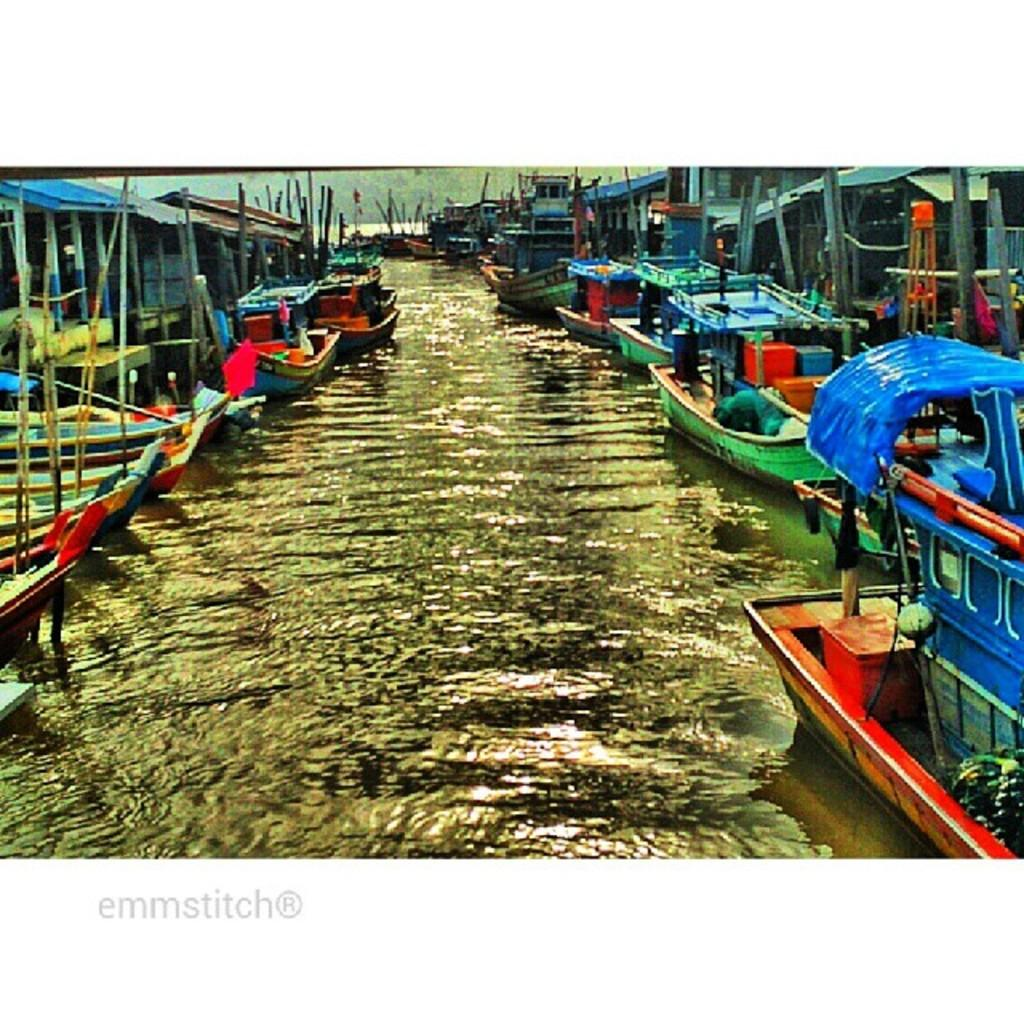What is the primary element visible in the image? There is water in the image. What is located on either side of the water? There are boats on either side of the water. Can you describe the boats in the background of the image? There are boats visible in the background of the image. What type of natural scenery is visible in the background? There are trees in the background of the image. What type of shade is provided by the moon in the image? The moon is not present in the image, so there is no shade provided by it. 